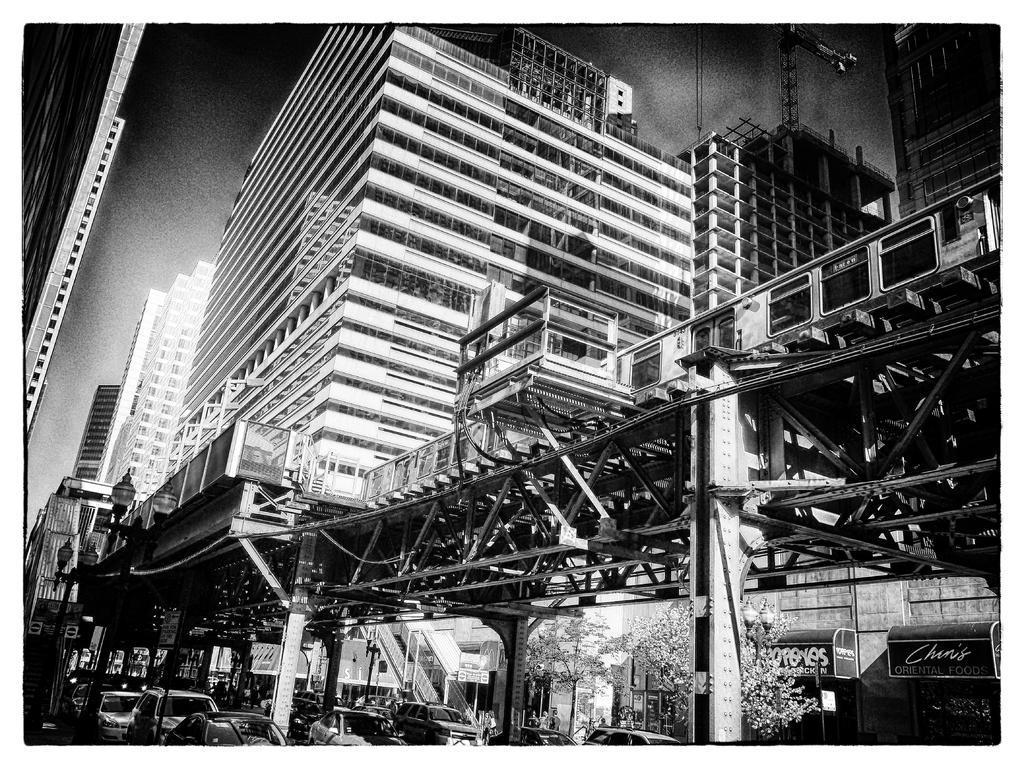How would you summarize this image in a sentence or two? In the foreground of the image we can see cars and trees. In the middle of the image we can see a train. On the top of the image we can see the building and the sky. By seeing this image we can say it is a photograph. 